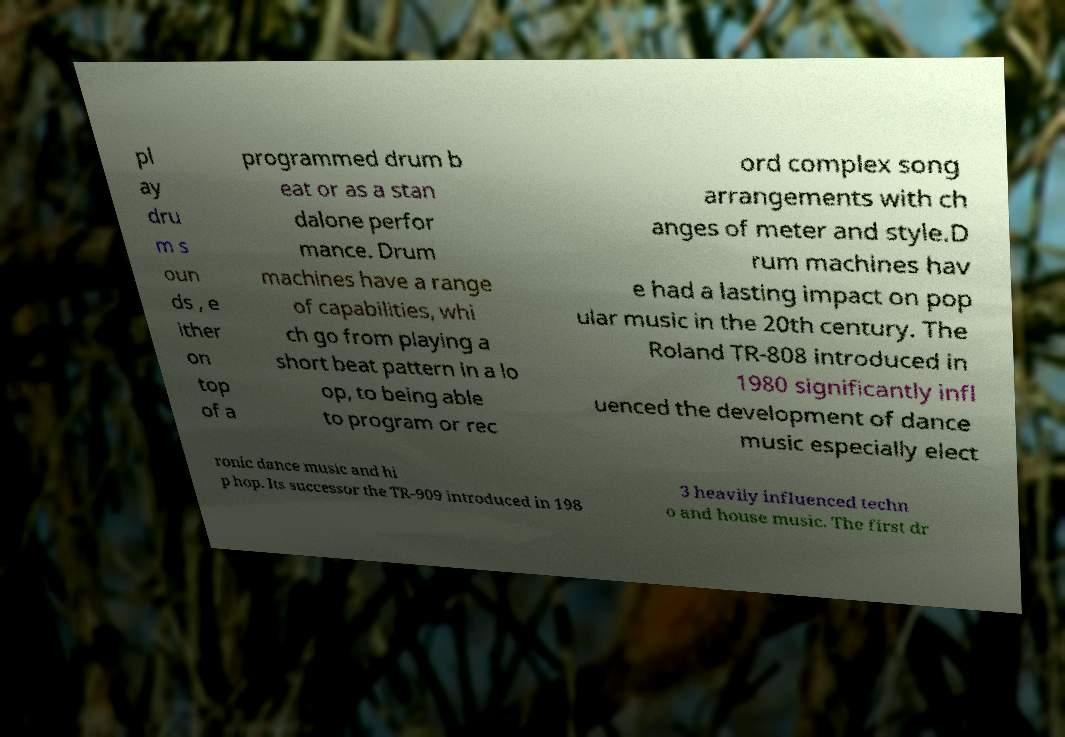Could you assist in decoding the text presented in this image and type it out clearly? pl ay dru m s oun ds , e ither on top of a programmed drum b eat or as a stan dalone perfor mance. Drum machines have a range of capabilities, whi ch go from playing a short beat pattern in a lo op, to being able to program or rec ord complex song arrangements with ch anges of meter and style.D rum machines hav e had a lasting impact on pop ular music in the 20th century. The Roland TR-808 introduced in 1980 significantly infl uenced the development of dance music especially elect ronic dance music and hi p hop. Its successor the TR-909 introduced in 198 3 heavily influenced techn o and house music. The first dr 